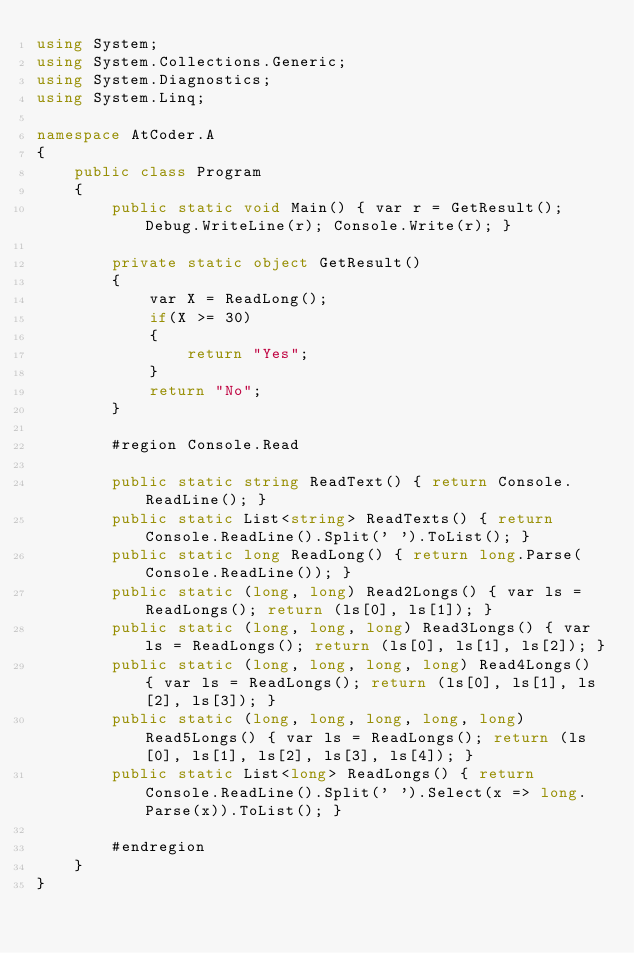Convert code to text. <code><loc_0><loc_0><loc_500><loc_500><_C#_>using System;
using System.Collections.Generic;
using System.Diagnostics;
using System.Linq;

namespace AtCoder.A
{
    public class Program
    {
        public static void Main() { var r = GetResult(); Debug.WriteLine(r); Console.Write(r); }

        private static object GetResult()
        {
            var X = ReadLong();
            if(X >= 30)
            {
                return "Yes";
            }
            return "No";
        }

        #region Console.Read

        public static string ReadText() { return Console.ReadLine(); }
        public static List<string> ReadTexts() { return Console.ReadLine().Split(' ').ToList(); }
        public static long ReadLong() { return long.Parse(Console.ReadLine()); }
        public static (long, long) Read2Longs() { var ls = ReadLongs(); return (ls[0], ls[1]); }
        public static (long, long, long) Read3Longs() { var ls = ReadLongs(); return (ls[0], ls[1], ls[2]); }
        public static (long, long, long, long) Read4Longs() { var ls = ReadLongs(); return (ls[0], ls[1], ls[2], ls[3]); }
        public static (long, long, long, long, long) Read5Longs() { var ls = ReadLongs(); return (ls[0], ls[1], ls[2], ls[3], ls[4]); }
        public static List<long> ReadLongs() { return Console.ReadLine().Split(' ').Select(x => long.Parse(x)).ToList(); }

        #endregion
    }
}
</code> 